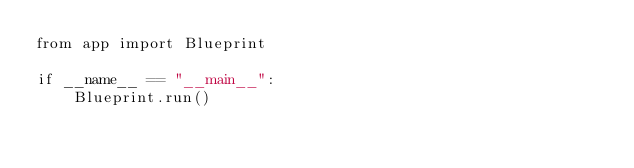<code> <loc_0><loc_0><loc_500><loc_500><_Python_>from app import Blueprint

if __name__ == "__main__":
    Blueprint.run()
</code> 